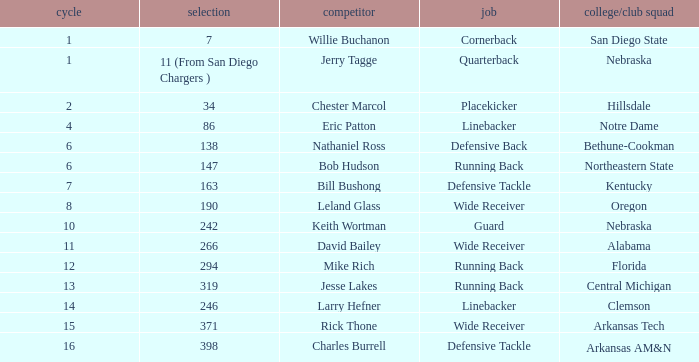Can you identify the player who has a pick of 147? Bob Hudson. 